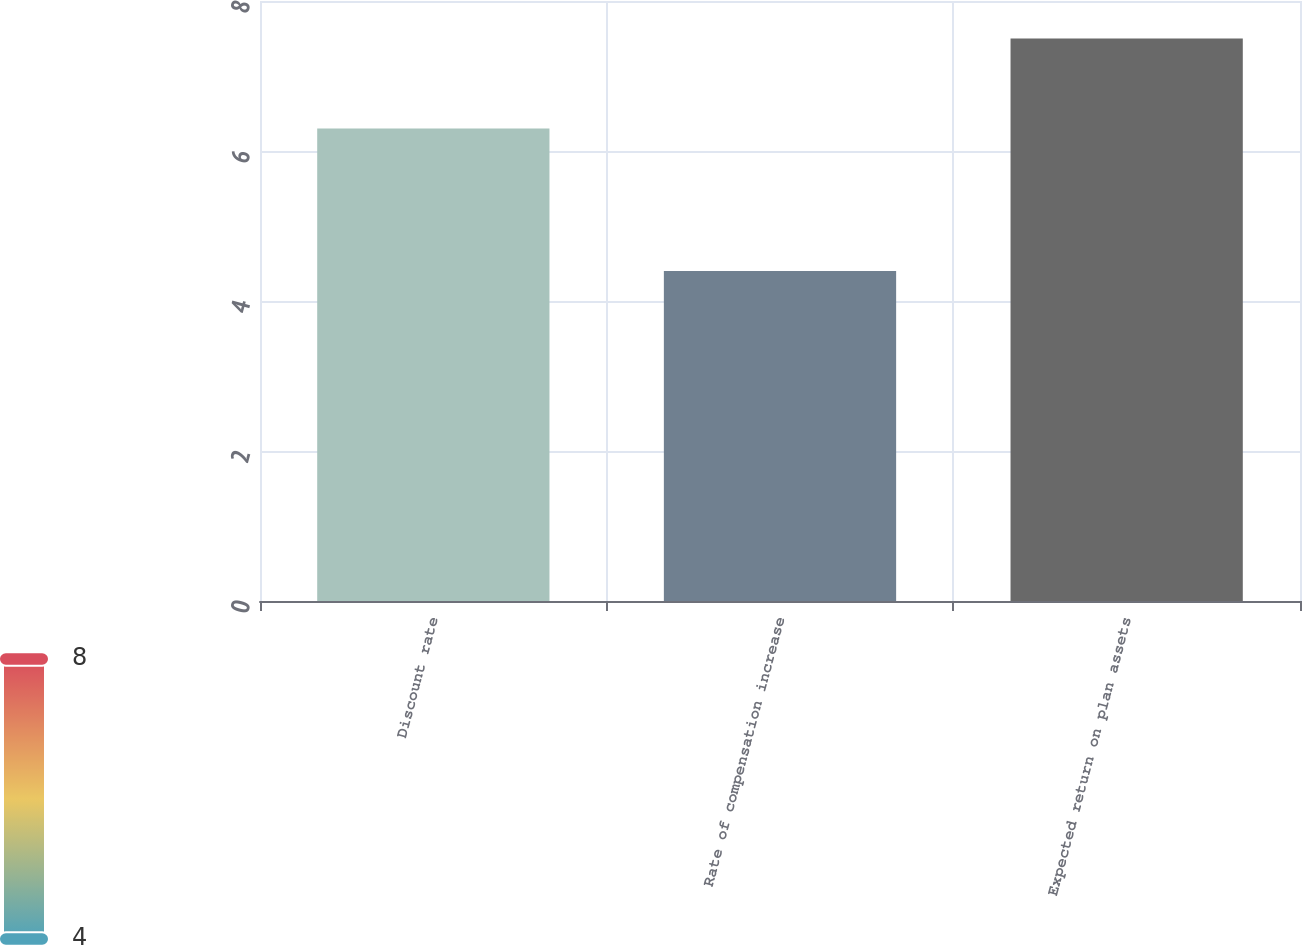Convert chart to OTSL. <chart><loc_0><loc_0><loc_500><loc_500><bar_chart><fcel>Discount rate<fcel>Rate of compensation increase<fcel>Expected return on plan assets<nl><fcel>6.3<fcel>4.4<fcel>7.5<nl></chart> 